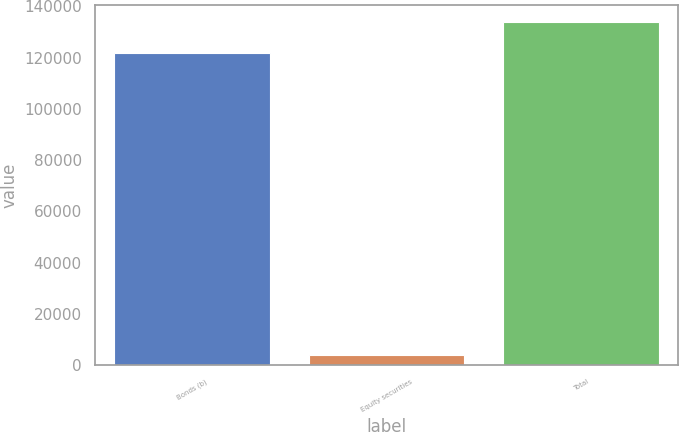Convert chart to OTSL. <chart><loc_0><loc_0><loc_500><loc_500><bar_chart><fcel>Bonds (b)<fcel>Equity securities<fcel>Total<nl><fcel>121631<fcel>3894<fcel>133794<nl></chart> 